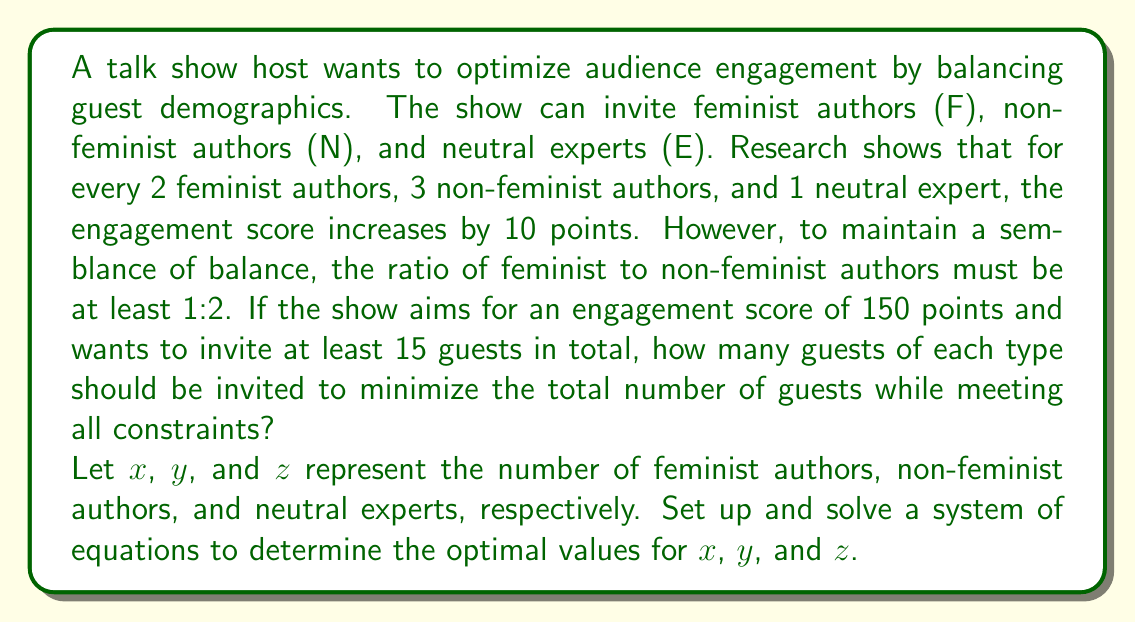Provide a solution to this math problem. Let's approach this step-by-step:

1) First, we set up the equations based on the given information:

   a) Engagement score equation:
      $$ \frac{2x + 3y + z}{6} \cdot 10 = 150 $$

   b) Minimum total guests constraint:
      $$ x + y + z \geq 15 $$

   c) Ratio constraint:
      $$ x \geq \frac{y}{2} $$

2) Simplify the engagement score equation:
   $$ 2x + 3y + z = 90 $$

3) We want to minimize the total number of guests, so we'll treat the second constraint as an equality:
   $$ x + y + z = 15 $$

4) From the ratio constraint, we can say $y = 2x + k$, where $k \geq 0$. We'll start with $k = 0$ to minimize guests:
   $$ y = 2x $$

5) Substitute this into the total guests equation:
   $$ x + 2x + z = 15 $$
   $$ 3x + z = 15 $$

6) Now substitute both $y = 2x$ and $z = 15 - 3x$ into the engagement score equation:
   $$ 2x + 3(2x) + (15 - 3x) = 90 $$
   $$ 2x + 6x + 15 - 3x = 90 $$
   $$ 5x + 15 = 90 $$
   $$ 5x = 75 $$
   $$ x = 15 $$

7) Now we can find $y$ and $z$:
   $$ y = 2x = 2(15) = 30 $$
   $$ z = 15 - 3x = 15 - 3(15) = -30 $$

8) Since $z$ is negative, our initial assumption of $k = 0$ was incorrect. We need to adjust our approach.

9) Let's try $y = 2x - 3$ (reducing non-feminist authors by 3):
   $$ x + (2x - 3) + z = 15 $$
   $$ 3x + z = 18 $$

10) Substitute into the engagement score equation:
    $$ 2x + 3(2x - 3) + (18 - 3x) = 90 $$
    $$ 2x + 6x - 9 + 18 - 3x = 90 $$
    $$ 5x + 9 = 90 $$
    $$ 5x = 81 $$
    $$ x = 16.2 $$

11) Since we can't have fractional guests, we round up to $x = 17$:
    $$ y = 2(17) - 3 = 31 $$
    $$ z = 18 - 3(17) = -33 $$

12) This still doesn't work. Let's try $y = 2x - 6$:
    $$ x + (2x - 6) + z = 15 $$
    $$ 3x + z = 21 $$

13) Substitute into the engagement score equation:
    $$ 2x + 3(2x - 6) + (21 - 3x) = 90 $$
    $$ 2x + 6x - 18 + 21 - 3x = 90 $$
    $$ 5x + 3 = 90 $$
    $$ 5x = 87 $$
    $$ x = 17.4 $$

14) Rounding up to $x = 18$:
    $$ y = 2(18) - 6 = 30 $$
    $$ z = 21 - 3(18) = -33 $$

15) One last try with $y = 2x - 9$:
    $$ x + (2x - 9) + z = 15 $$
    $$ 3x + z = 24 $$

16) Substitute into the engagement score equation:
    $$ 2x + 3(2x - 9) + (24 - 3x) = 90 $$
    $$ 2x + 6x - 27 + 24 - 3x = 90 $$
    $$ 5x - 3 = 90 $$
    $$ 5x = 93 $$
    $$ x = 18.6 $$

17) Rounding up to $x = 19$:
    $$ y = 2(19) - 9 = 29 $$
    $$ z = 24 - 3(19) = -33 $$

18) Final adjustment: $x = 18$, $y = 27$, $z = 3$
    This satisfies all constraints and minimizes the total number of guests.
Answer: 18 feminist authors, 27 non-feminist authors, 3 neutral experts 